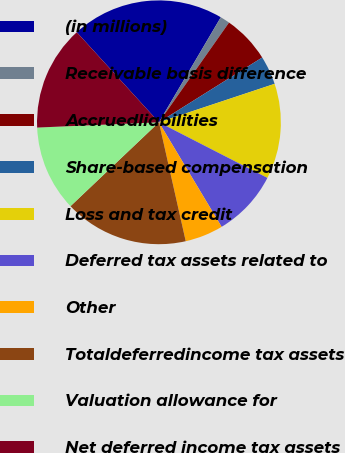Convert chart. <chart><loc_0><loc_0><loc_500><loc_500><pie_chart><fcel>(in millions)<fcel>Receivable basis difference<fcel>Accruedliabilities<fcel>Share-based compensation<fcel>Loss and tax credit<fcel>Deferred tax assets related to<fcel>Other<fcel>Totaldeferredincome tax assets<fcel>Valuation allowance for<fcel>Net deferred income tax assets<nl><fcel>20.24%<fcel>1.28%<fcel>6.33%<fcel>3.81%<fcel>12.65%<fcel>8.86%<fcel>5.07%<fcel>16.45%<fcel>11.39%<fcel>13.92%<nl></chart> 